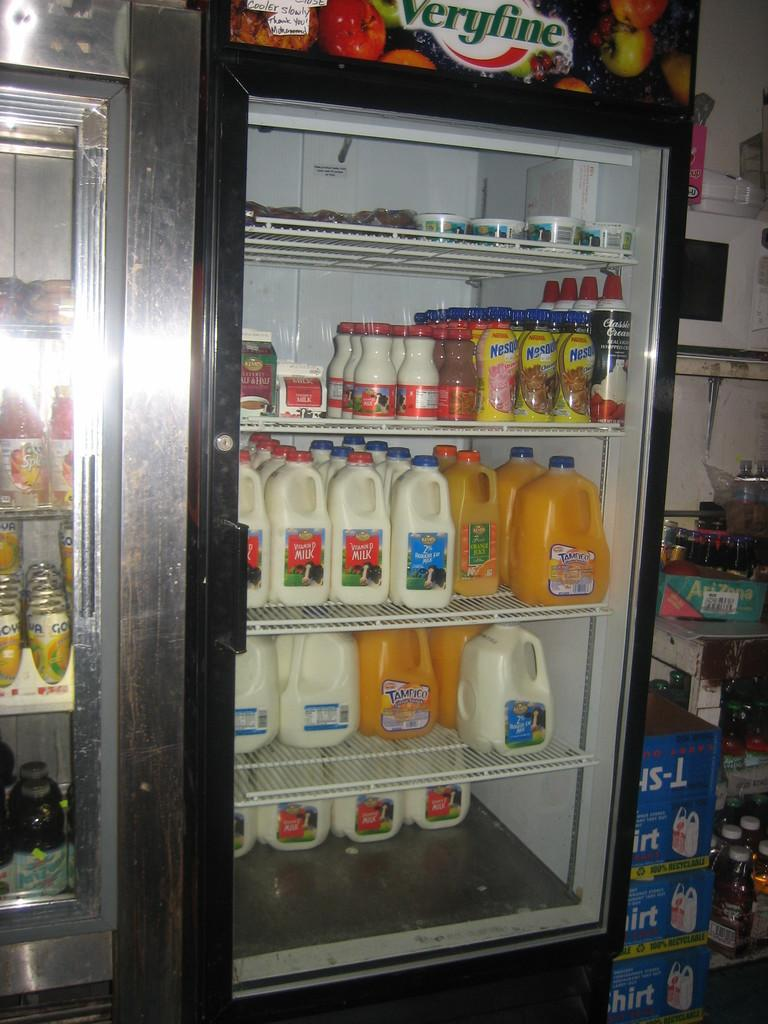Provide a one-sentence caption for the provided image. A cooler containing milk, whipped cream orange juice and Nestle drinks. 